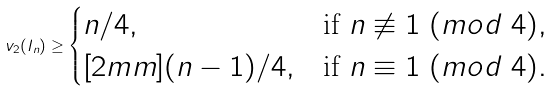Convert formula to latex. <formula><loc_0><loc_0><loc_500><loc_500>v _ { 2 } ( I _ { n } ) \geq \begin{cases} { n } / { 4 } , & \text {if $n\not\equiv 1\ (mod\ 4)$} , \\ [ 2 m m ] ( { n - 1 } ) / { 4 } , & \text {if $n\equiv 1\ (mod\ 4)$} . \end{cases}</formula> 